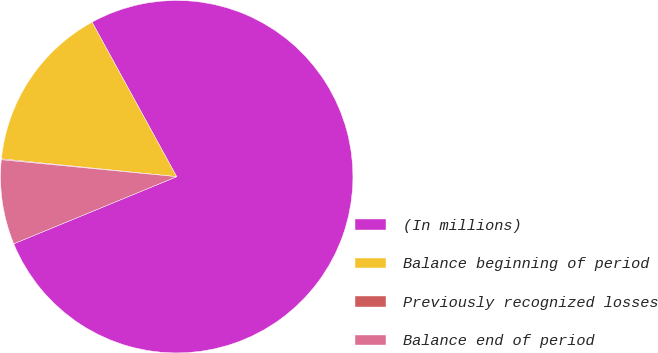Convert chart to OTSL. <chart><loc_0><loc_0><loc_500><loc_500><pie_chart><fcel>(In millions)<fcel>Balance beginning of period<fcel>Previously recognized losses<fcel>Balance end of period<nl><fcel>76.76%<fcel>15.41%<fcel>0.08%<fcel>7.75%<nl></chart> 